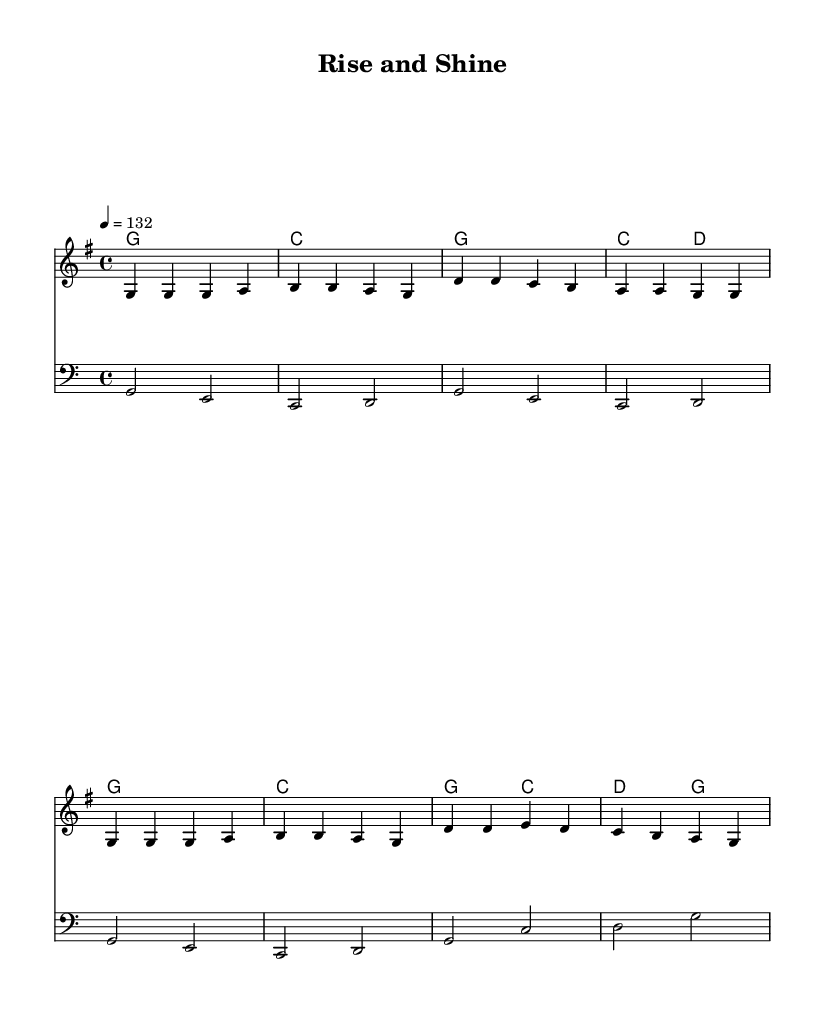What is the key signature of this music? The key signature is G major, which has one sharp (F#). This can be identified by looking at the key signature indicated at the beginning of the score.
Answer: G major What is the time signature of the piece? The time signature is 4/4, as shown at the beginning of the score immediately following the key signature. This indicates that there are four beats in each measure and the quarter note gets one beat.
Answer: 4/4 What tempo marking is indicated in the sheet music? The tempo marking is 132 beats per minute, indicated with the text "4 = 132" within the global section of the score. This guides performers on how fast to play the piece.
Answer: 132 How many measures are in the melody section? The melody section contains eight measures, which can be counted by observing the bar lines in the notation. Each grouping of music separated by a vertical line represents a measure.
Answer: 8 What is the primary theme of the lyrics? The primary theme of the lyrics revolves around entrepreneurship and success, as indicated by phrases like "Build your dreams" and "Entrepreneur spirit comes alive." The lyrics celebrate ambition and hard work.
Answer: Entrepreneurship What is the highest pitch note in the melody? The highest pitch note in the melody is D, which appears as the first note in the third measure. The notes are arranged in ascending order and D is the highest seen in this part.
Answer: D How are the harmonies structured in the music? The harmonies are structured around simple triads, primarily using G and C major chords, alternating with D and their respective bass notes, which reinforces the upbeat and celebratory nature of the piece.
Answer: Triads 